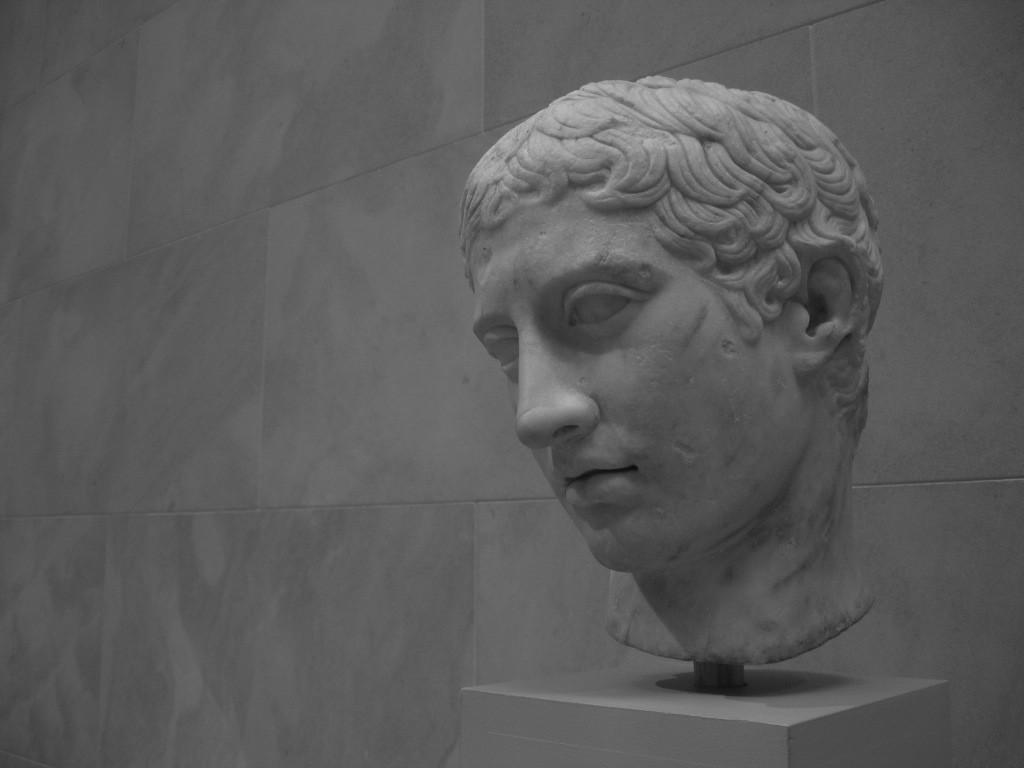Where was the picture taken? The picture was clicked outside. What can be seen on the right side of the image? There is a sculpture of a person's head on the right side of the image. What is visible in the background of the image? There is a wall in the background of the image. What song is being sung by the cattle in the image? There are no cattle or any indication of singing in the image. 